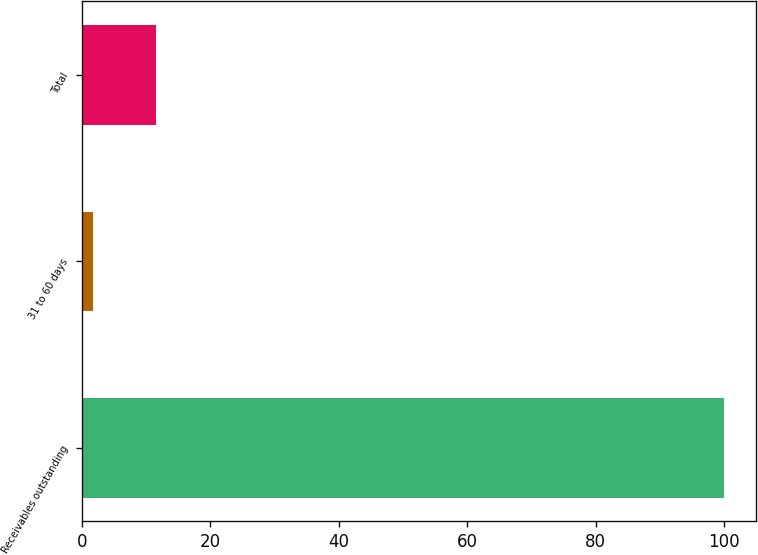<chart> <loc_0><loc_0><loc_500><loc_500><bar_chart><fcel>Receivables outstanding<fcel>31 to 60 days<fcel>Total<nl><fcel>100<fcel>1.8<fcel>11.62<nl></chart> 